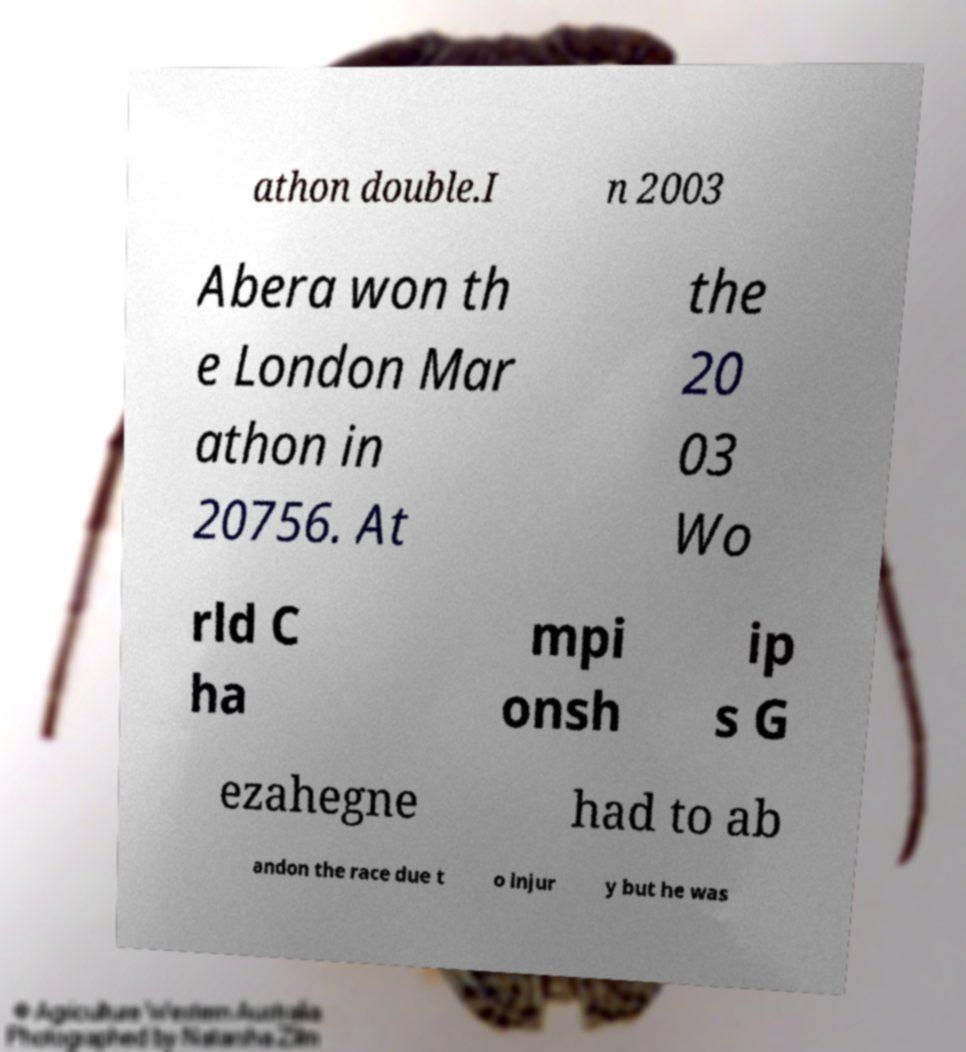For documentation purposes, I need the text within this image transcribed. Could you provide that? athon double.I n 2003 Abera won th e London Mar athon in 20756. At the 20 03 Wo rld C ha mpi onsh ip s G ezahegne had to ab andon the race due t o injur y but he was 